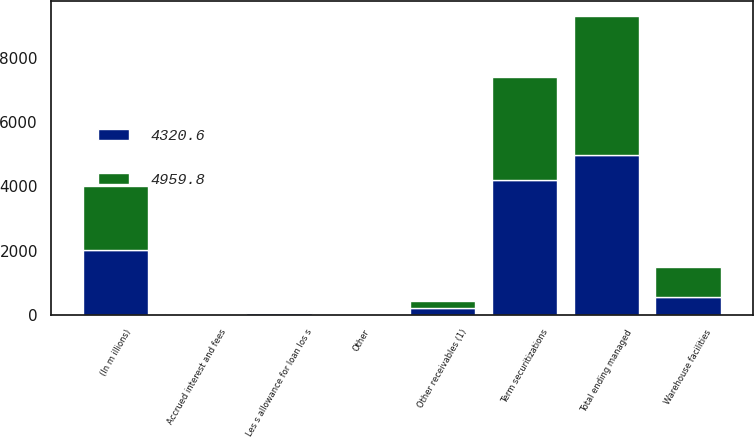Convert chart to OTSL. <chart><loc_0><loc_0><loc_500><loc_500><stacked_bar_chart><ecel><fcel>(In m illions)<fcel>Warehouse facilities<fcel>Term securitizations<fcel>Other receivables (1)<fcel>Total ending managed<fcel>Accrued interest and fees<fcel>Other<fcel>Les s allowance for loan los s<nl><fcel>4320.6<fcel>2012<fcel>553<fcel>4211.8<fcel>217<fcel>4981.8<fcel>23.1<fcel>1.8<fcel>43.3<nl><fcel>4959.8<fcel>2011<fcel>943<fcel>3193.1<fcel>198.5<fcel>4334.6<fcel>20.9<fcel>4<fcel>38.9<nl></chart> 